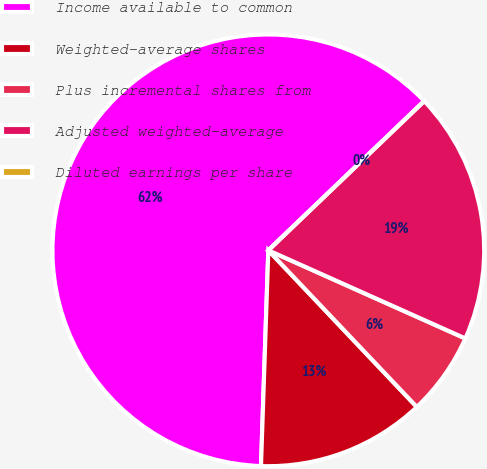<chart> <loc_0><loc_0><loc_500><loc_500><pie_chart><fcel>Income available to common<fcel>Weighted-average shares<fcel>Plus incremental shares from<fcel>Adjusted weighted-average<fcel>Diluted earnings per share<nl><fcel>62.31%<fcel>12.62%<fcel>6.23%<fcel>18.85%<fcel>0.0%<nl></chart> 